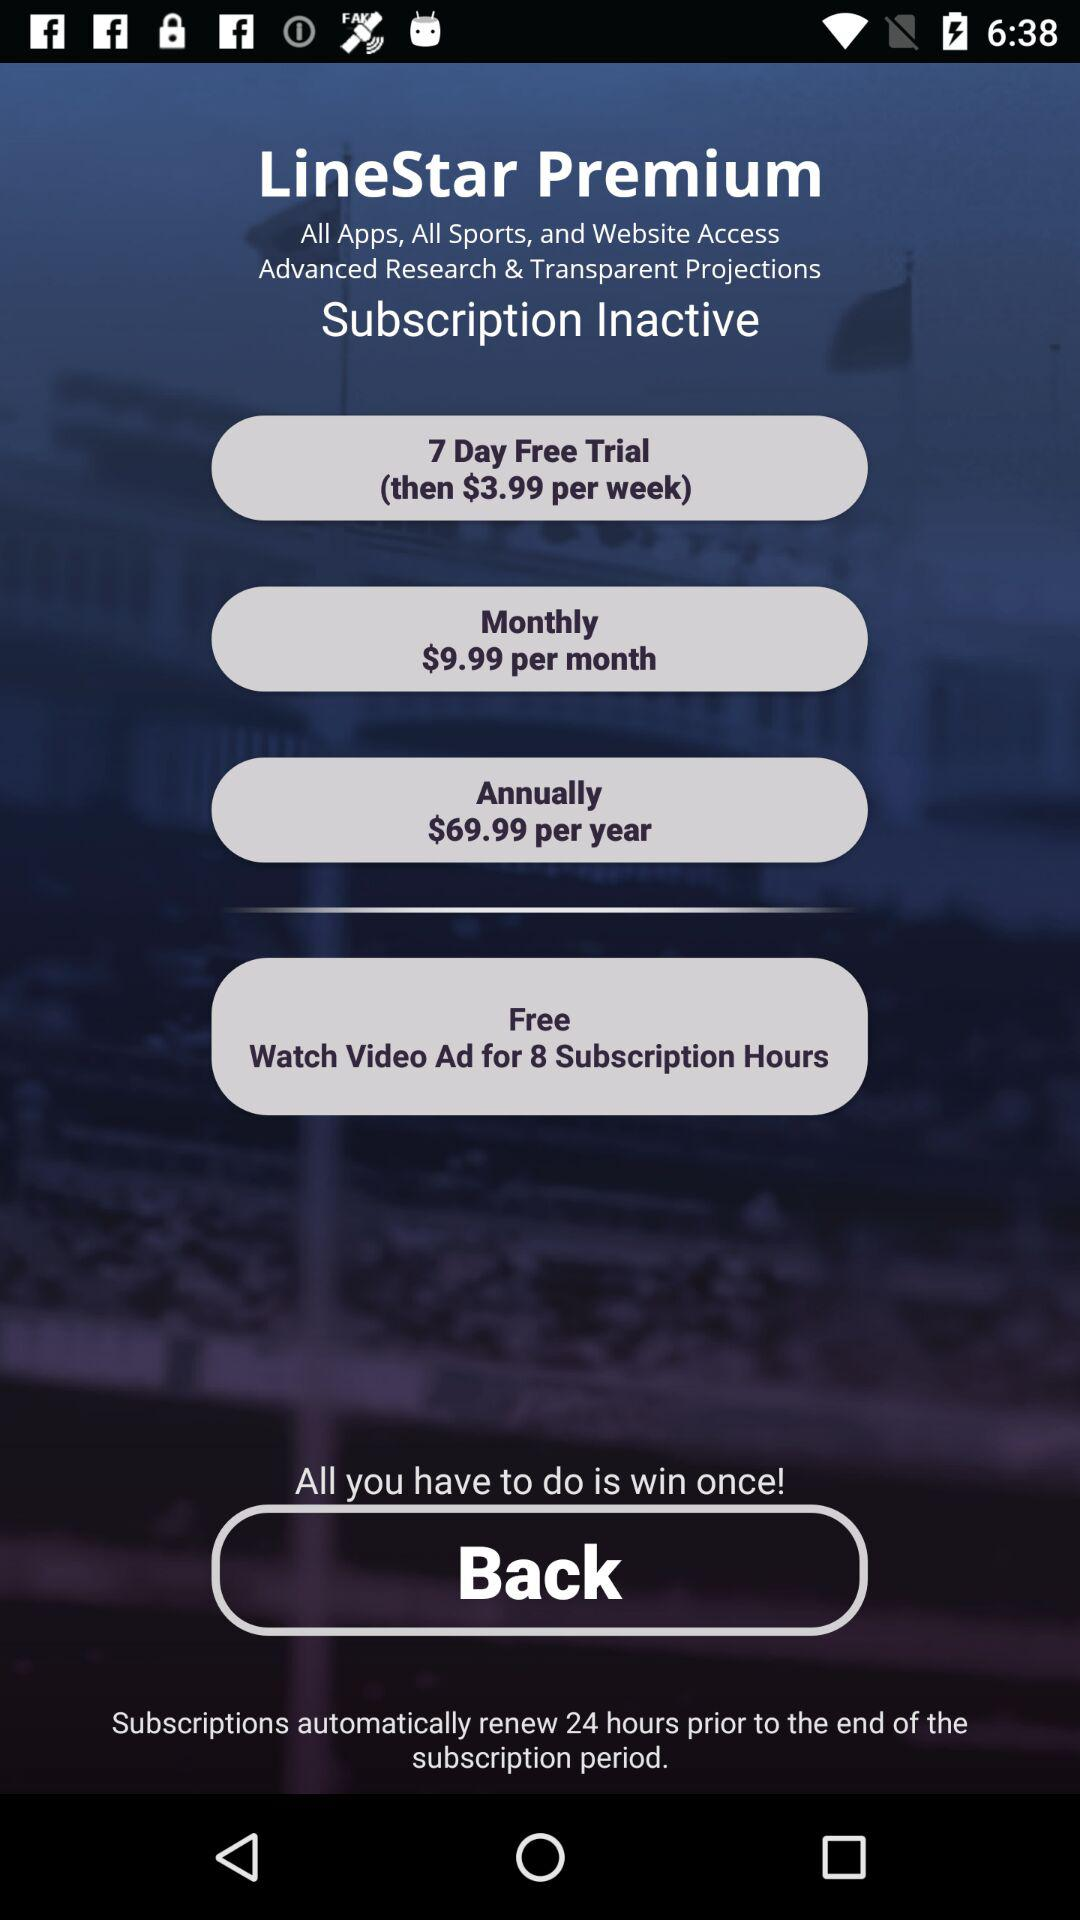How many free hours of subscription can I get by watching a video ad?
Answer the question using a single word or phrase. 8 